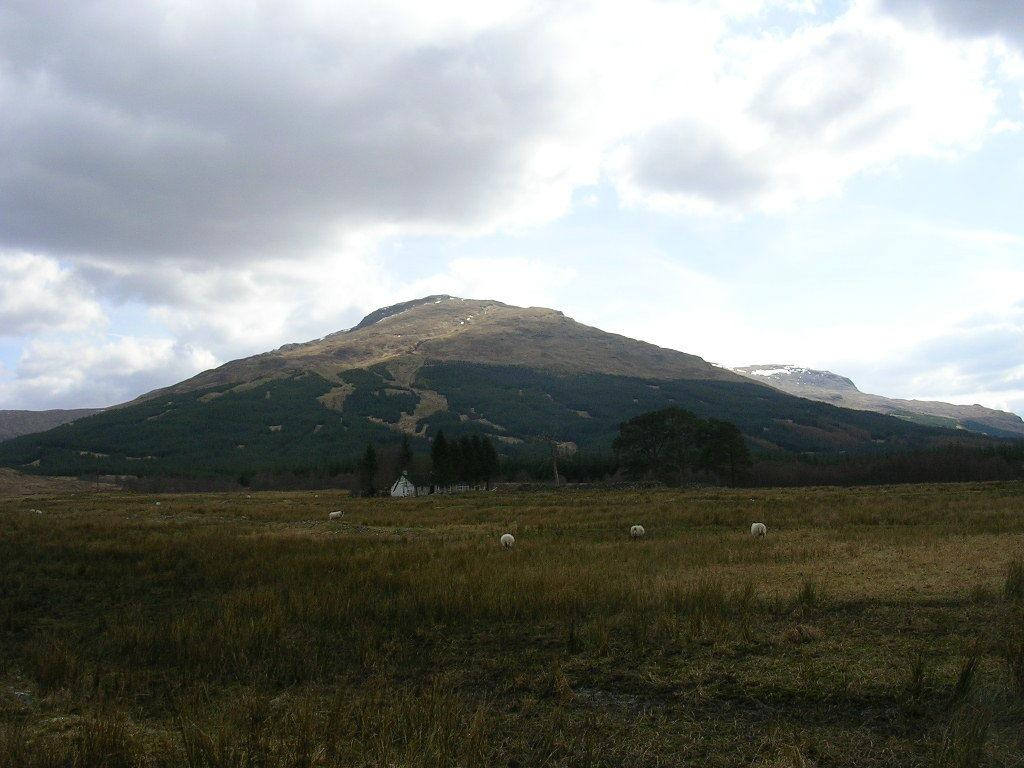What type of living organisms can be seen in the image? There are animals in the image. What type of vegetation is present in the image? There is grass and trees in the image. What type of terrain is visible in the image? There are hills in the image. What is visible in the sky in the image? There are clouds visible in the image. Which actor is performing on the land in the image? There is no actor or performance present in the image; it features animals, grass, trees, hills, and clouds. What type of grape can be seen growing on the trees in the image? There are no grapes present in the image, as the trees are not fruit-bearing trees. 